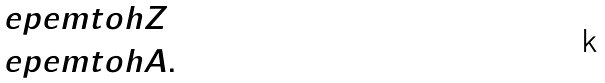<formula> <loc_0><loc_0><loc_500><loc_500>& \ e p e m t o h Z \\ & \ e p e m t o h A .</formula> 